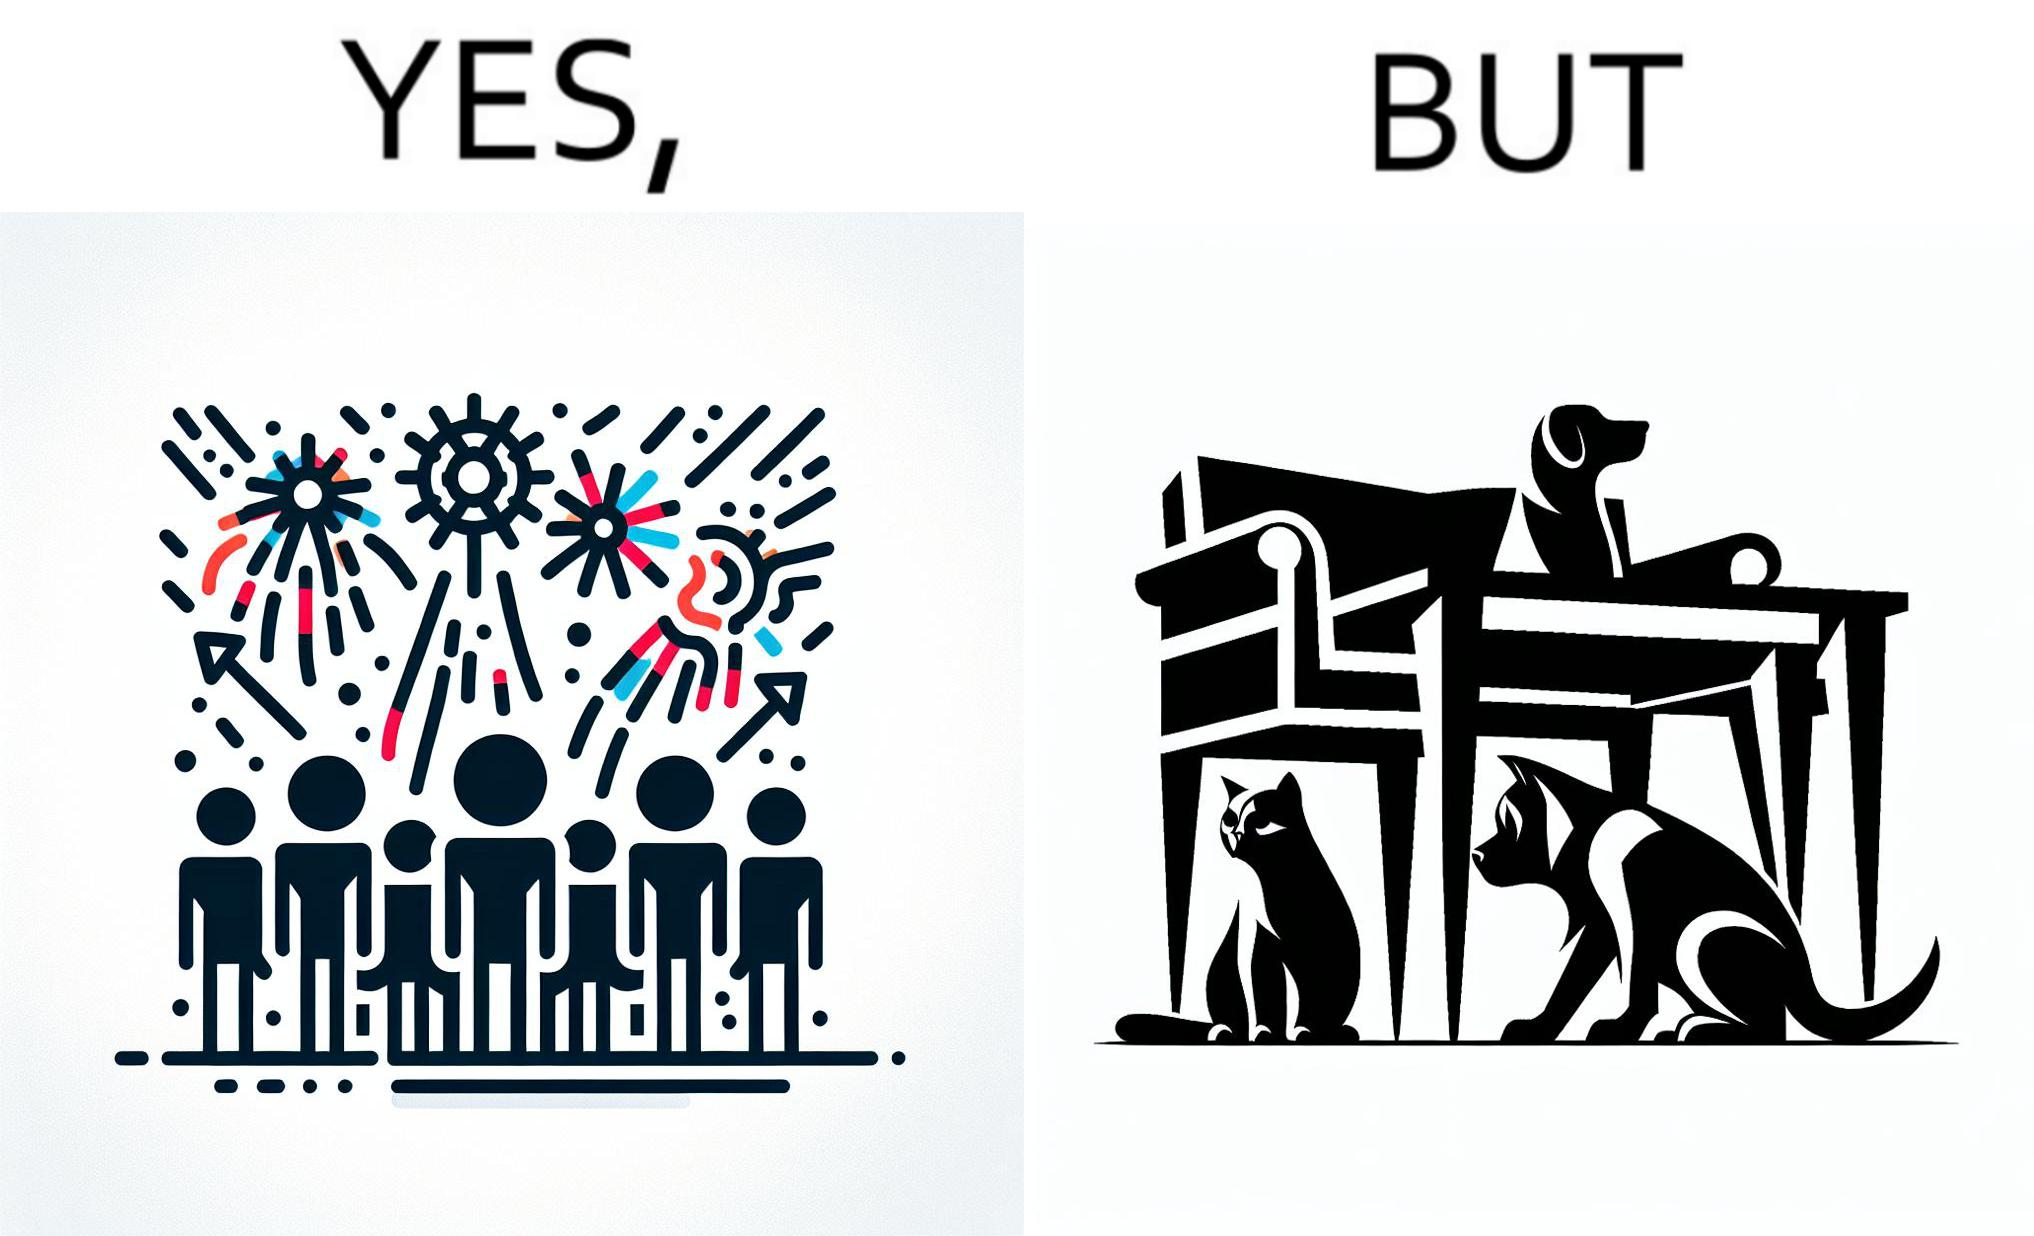Is this image satirical or non-satirical? Yes, this image is satirical. 